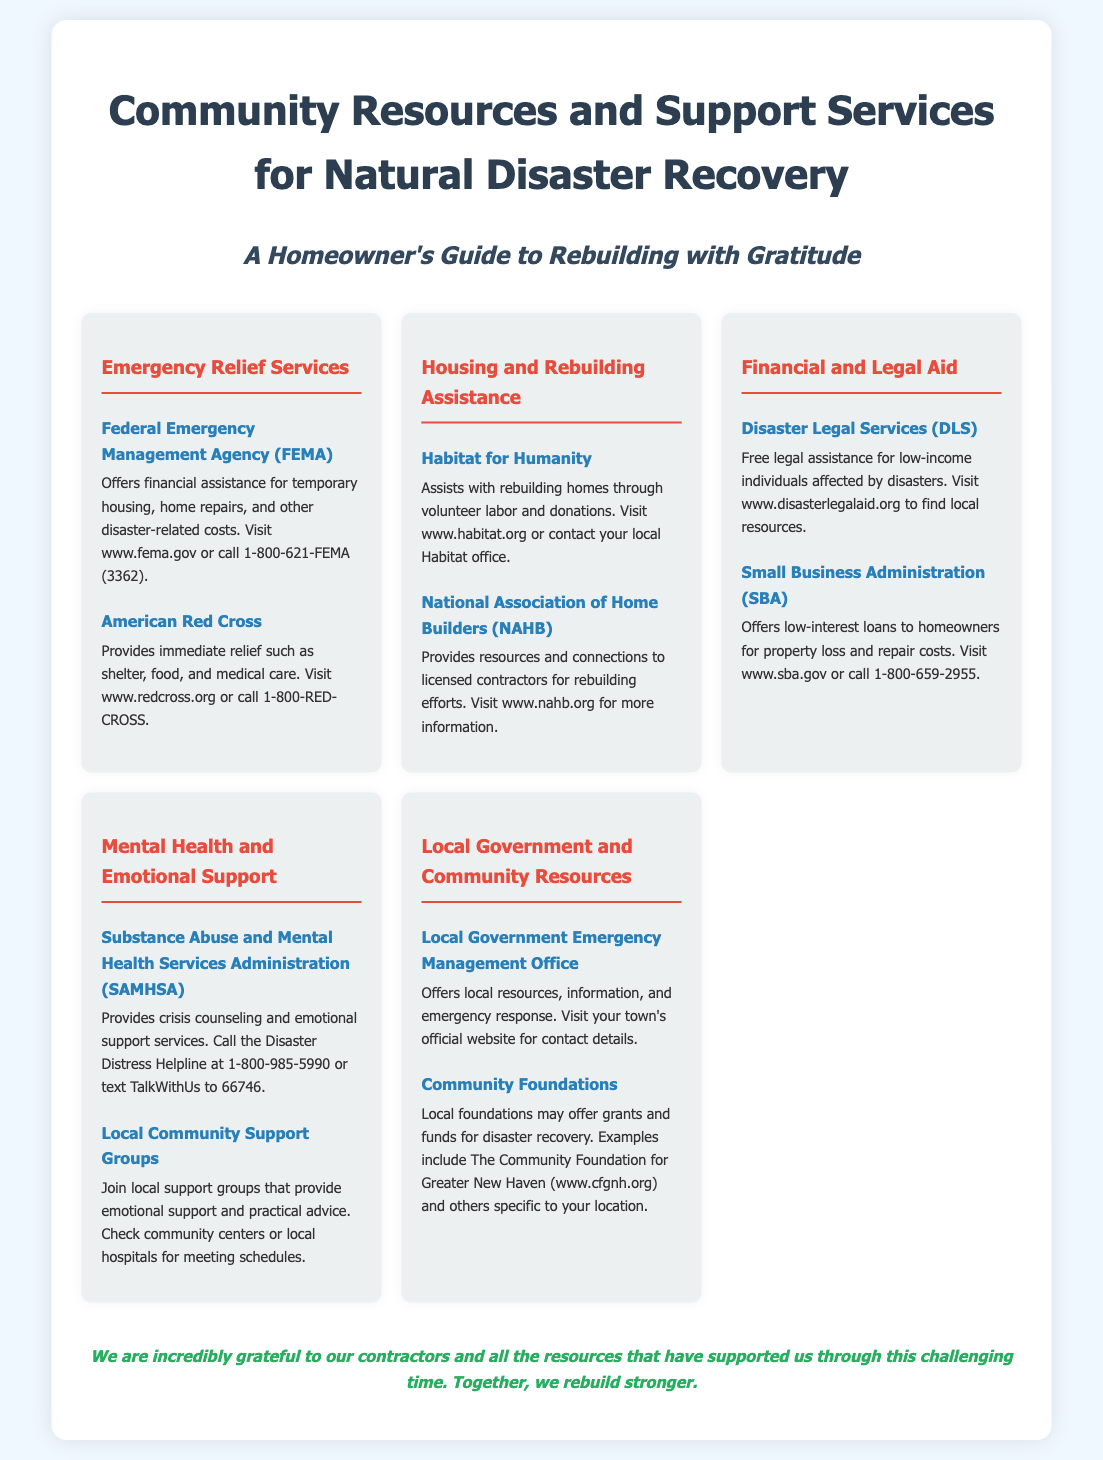What is the purpose of FEMA? FEMA offers financial assistance for temporary housing, home repairs, and other disaster-related costs.
Answer: Financial assistance for temporary housing What organization provides immediate relief such as shelter and food? The American Red Cross is mentioned as providing immediate relief such as shelter, food, and medical care.
Answer: American Red Cross Which organization assists with rebuilding homes through volunteer labor? Habitat for Humanity is highlighted for assisting with rebuilding homes through volunteer labor and donations.
Answer: Habitat for Humanity What type of loans does the Small Business Administration offer? The SBA offers low-interest loans to homeowners for property loss and repair costs.
Answer: Low-interest loans What is one local resource for mental health support? The Substance Abuse and Mental Health Services Administration provides crisis counseling and emotional support services.
Answer: SAMHSA Which section of the poster discusses legal assistance? The Financial and Legal Aid section provides information about free legal assistance for low-income individuals affected by disasters.
Answer: Financial and Legal Aid What does the poster emphasize about contractors? The closing line expresses gratitude for contractors who supported during the recovery.
Answer: Gratitude for contractors Where can you find local foundations that may offer disaster recovery funds? Community Foundations in the Local Government and Community Resources section provide a reference to local foundations for disaster recovery.
Answer: Community Foundations 